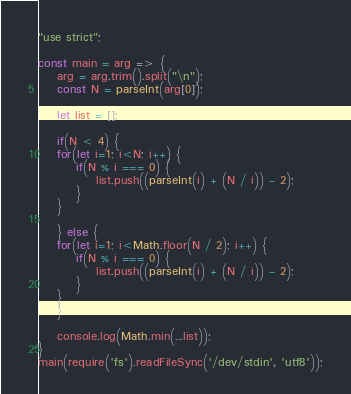<code> <loc_0><loc_0><loc_500><loc_500><_JavaScript_>"use strict";

const main = arg => {
    arg = arg.trim().split("\n");
    const N = parseInt(arg[0]);
    
    let list = [];
    
    if(N < 4) {
    for(let i=1; i<N; i++) {
        if(N % i === 0) {
            list.push((parseInt(i) + (N / i)) - 2);
        }
    }
    
    } else {
    for(let i=1; i<Math.floor(N / 2); i++) {
        if(N % i === 0) {
            list.push((parseInt(i) + (N / i)) - 2);
        }
    }
    }

    console.log(Math.min(...list));
}
main(require('fs').readFileSync('/dev/stdin', 'utf8'));
</code> 